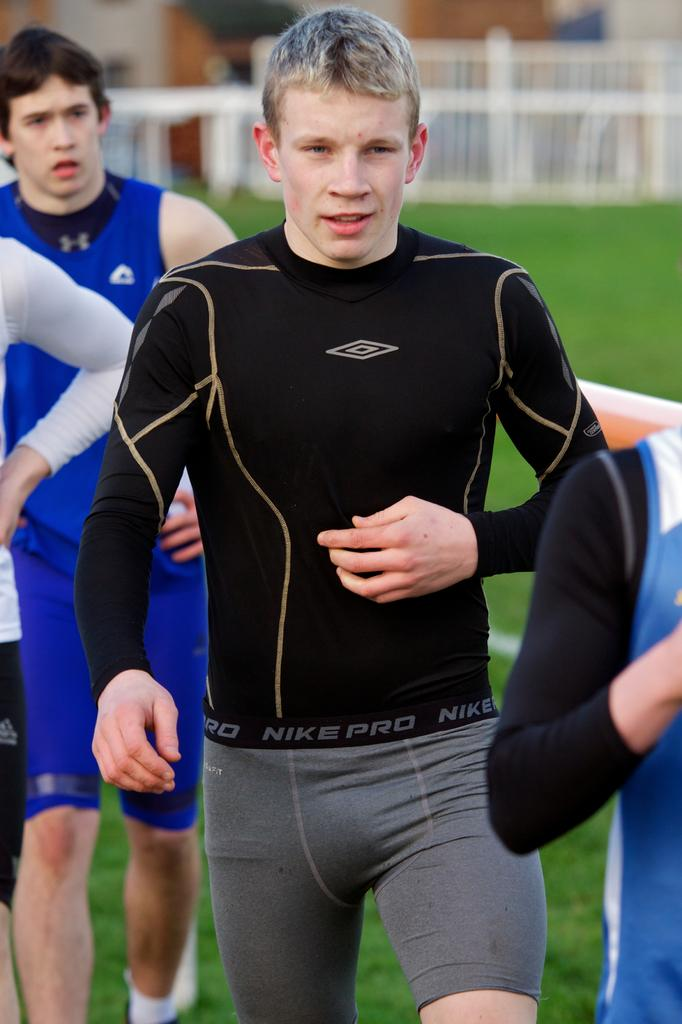How many people are present in the image? There are four persons in the image. Where are the persons located? The persons are on the grass. What can be seen behind the people? There is fencing visible behind the people. Can you describe the background of the image? The background of the image is blurred. How many babies are crawling on the grass in the image? There are no babies present in the image; it features four persons. What type of structure is visible behind the people? There is no structure visible behind the people; only fencing can be seen. 